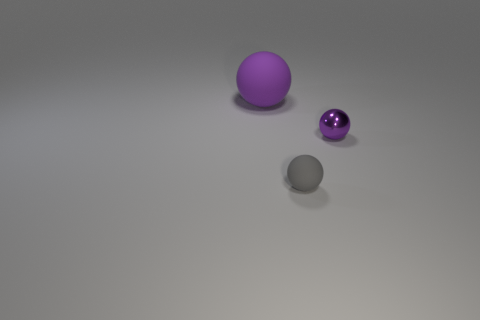Add 1 small yellow matte balls. How many objects exist? 4 Add 2 tiny yellow matte balls. How many tiny yellow matte balls exist? 2 Subtract 0 cyan balls. How many objects are left? 3 Subtract all small rubber spheres. Subtract all tiny purple spheres. How many objects are left? 1 Add 2 tiny spheres. How many tiny spheres are left? 4 